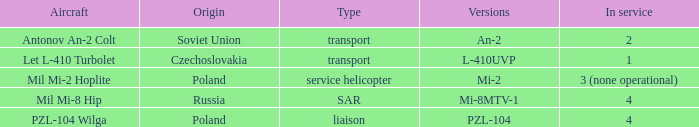Provide details on the plane for pzl-10 PZL-104 Wilga. 